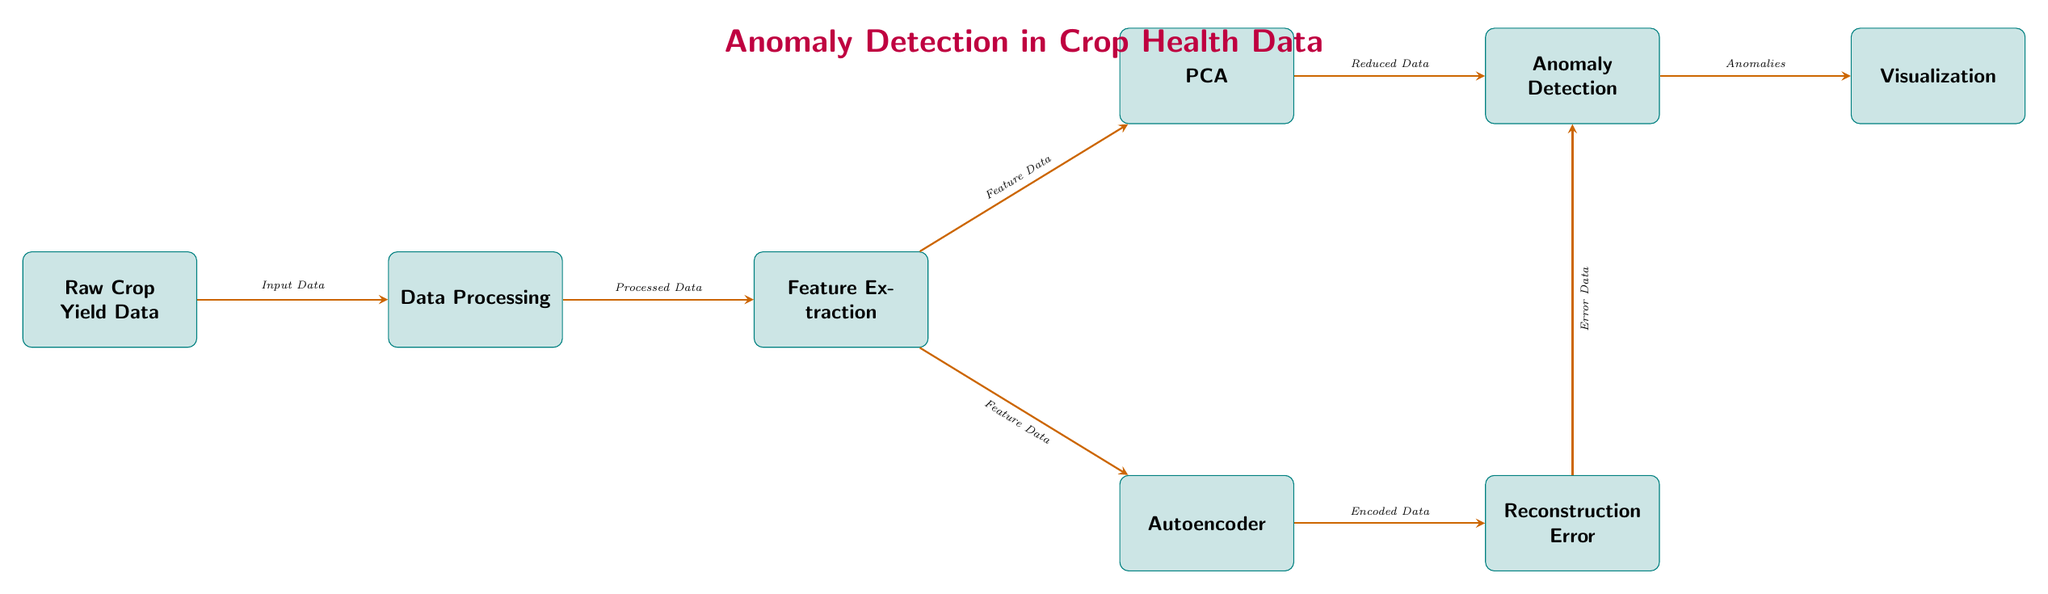What is the starting node in this diagram? The starting node is indicated as "Raw Crop Yield Data," which is the first element in the flow of the diagram.
Answer: Raw Crop Yield Data How many main processing steps are there after the Data Processing node? There are two main processing steps indicated after the Data Processing node: Feature Extraction and PCA or Autoencoder.
Answer: Two What type of data is used as input for Anomaly Detection? The input for Anomaly Detection comes from either the "Reduced Data" from PCA or the "Error Data" from the autoencoder, showing that both approaches contribute data for this purpose.
Answer: Reduced Data or Error Data Which process follows directly after Reconstruction Error? The process that follows directly after Reconstruction Error is Anomaly Detection, as indicated by the arrow connecting the two nodes.
Answer: Anomaly Detection Describe the purpose of the Visualization node. The Visualization node is designed to present the output from the Anomaly Detection step, highlighting the identified anomalies in the crop health data for easy interpretation.
Answer: To visualize anomalies What is the output of the dimensionality reduction step? The output of the dimensionality reduction step is "Reduced Data," which is used in the subsequent Anomaly Detection process.
Answer: Reduced Data Which two processes receive the same input before their respective outputs? Both PCA and Autoencoder receive the same input from Feature Extraction, indicating that they utilize the same processed data to perform different tasks.
Answer: PCA and Autoencoder What is the function of the arrow from Autoencoder to Reconstruction Error? The arrow indicates that the "Encoded Data" from the Autoencoder is used to calculate the Reconstruction Error, which is a key metric for assessing the model's performance regarding the anomalies.
Answer: Encoded Data How does the diagram show the flow of data between nodes? The flow of data is depicted with arrows pointing from one node to another, indicating the sequence of processes that data undergoes in the anomaly detection framework.
Answer: Through arrows 